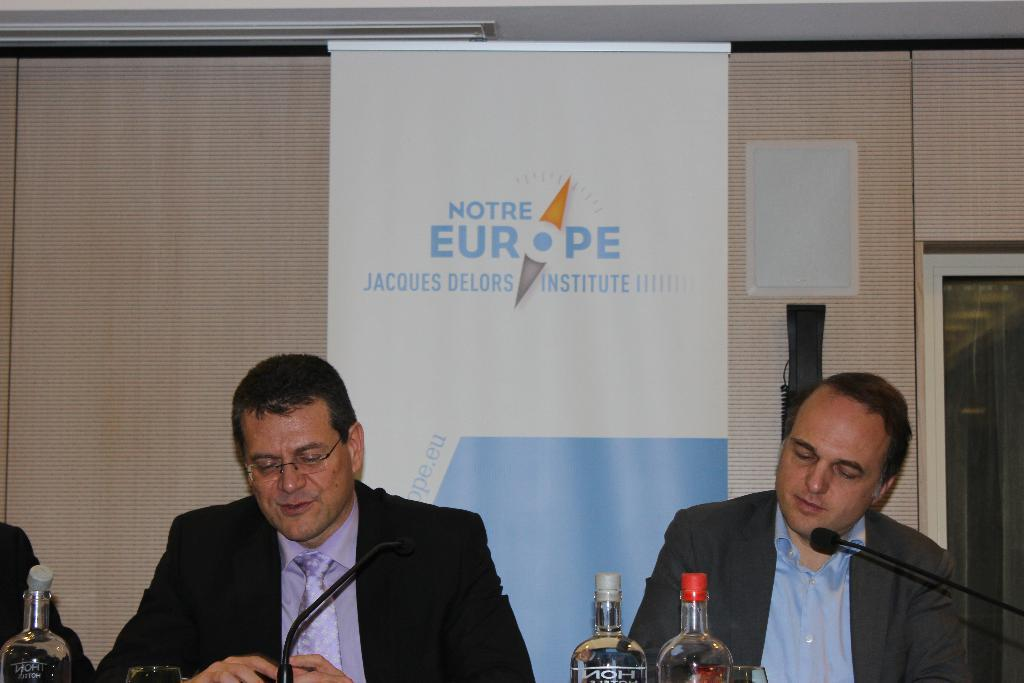<image>
Give a short and clear explanation of the subsequent image. Two men sit at microphones in front of a sign saying Notre Europe Jacques Delors Institute. 